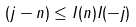<formula> <loc_0><loc_0><loc_500><loc_500>( j - n ) \leq I ( n ) I ( - j )</formula> 